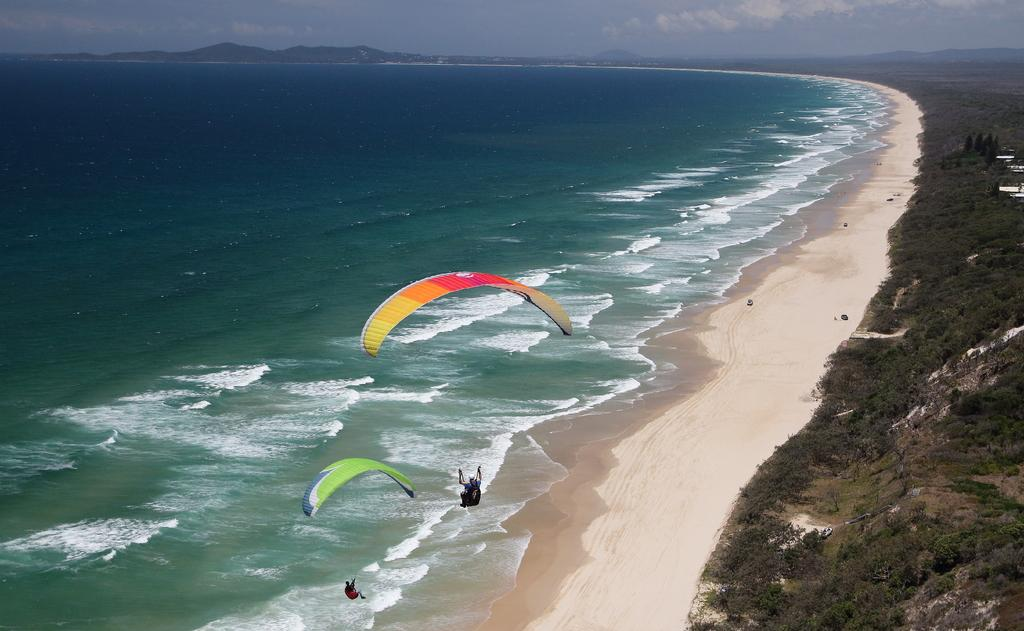How many people are in the image? There are two persons in the image. What are the persons using in the image? The persons are using parachutes in the image. What can be seen in the background of the image? There are trees, water, sand, waves, hills, and a cloudy sky visible in the background of the image. What color is the crayon being used by the servant in the image? There is no servant or crayon present in the image. How many geese are flying in the image? There are no geese visible in the image. 